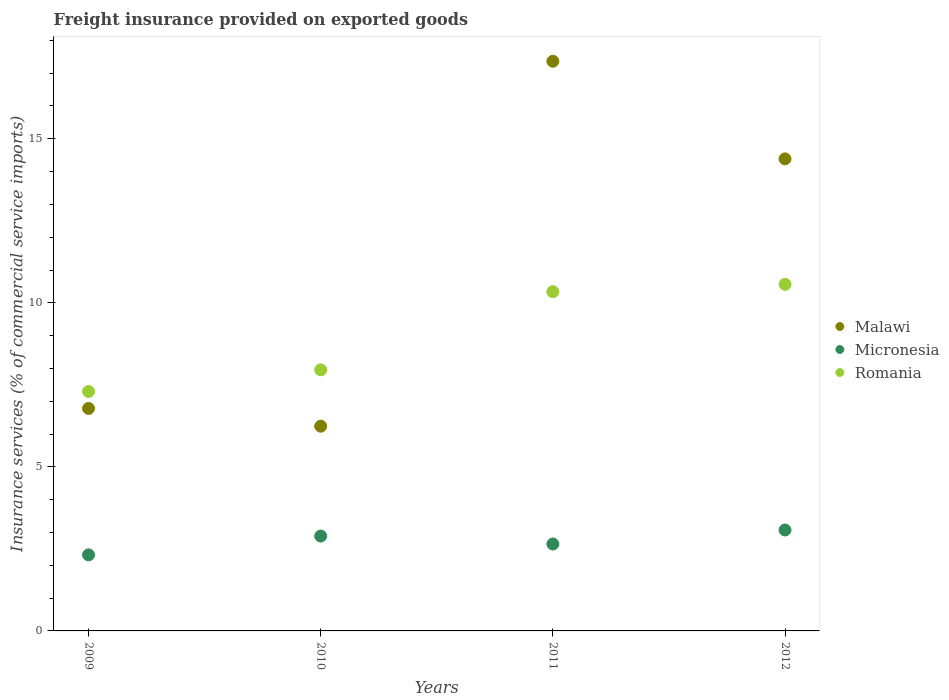Is the number of dotlines equal to the number of legend labels?
Provide a succinct answer. Yes. What is the freight insurance provided on exported goods in Romania in 2011?
Provide a short and direct response. 10.34. Across all years, what is the maximum freight insurance provided on exported goods in Micronesia?
Your answer should be very brief. 3.08. Across all years, what is the minimum freight insurance provided on exported goods in Malawi?
Your answer should be compact. 6.24. In which year was the freight insurance provided on exported goods in Malawi maximum?
Provide a short and direct response. 2011. In which year was the freight insurance provided on exported goods in Malawi minimum?
Provide a succinct answer. 2010. What is the total freight insurance provided on exported goods in Micronesia in the graph?
Make the answer very short. 10.94. What is the difference between the freight insurance provided on exported goods in Romania in 2009 and that in 2011?
Offer a very short reply. -3.04. What is the difference between the freight insurance provided on exported goods in Malawi in 2011 and the freight insurance provided on exported goods in Romania in 2012?
Offer a terse response. 6.8. What is the average freight insurance provided on exported goods in Romania per year?
Provide a succinct answer. 9.04. In the year 2011, what is the difference between the freight insurance provided on exported goods in Romania and freight insurance provided on exported goods in Micronesia?
Ensure brevity in your answer.  7.69. What is the ratio of the freight insurance provided on exported goods in Micronesia in 2010 to that in 2011?
Ensure brevity in your answer.  1.09. What is the difference between the highest and the second highest freight insurance provided on exported goods in Malawi?
Keep it short and to the point. 2.98. What is the difference between the highest and the lowest freight insurance provided on exported goods in Romania?
Your answer should be very brief. 3.27. Does the freight insurance provided on exported goods in Malawi monotonically increase over the years?
Make the answer very short. No. Is the freight insurance provided on exported goods in Micronesia strictly greater than the freight insurance provided on exported goods in Romania over the years?
Offer a very short reply. No. Is the freight insurance provided on exported goods in Malawi strictly less than the freight insurance provided on exported goods in Micronesia over the years?
Ensure brevity in your answer.  No. Are the values on the major ticks of Y-axis written in scientific E-notation?
Your response must be concise. No. Does the graph contain any zero values?
Provide a short and direct response. No. How many legend labels are there?
Offer a very short reply. 3. What is the title of the graph?
Your answer should be compact. Freight insurance provided on exported goods. Does "Saudi Arabia" appear as one of the legend labels in the graph?
Give a very brief answer. No. What is the label or title of the X-axis?
Ensure brevity in your answer.  Years. What is the label or title of the Y-axis?
Offer a very short reply. Insurance services (% of commercial service imports). What is the Insurance services (% of commercial service imports) of Malawi in 2009?
Provide a short and direct response. 6.78. What is the Insurance services (% of commercial service imports) in Micronesia in 2009?
Provide a short and direct response. 2.32. What is the Insurance services (% of commercial service imports) of Romania in 2009?
Offer a terse response. 7.3. What is the Insurance services (% of commercial service imports) of Malawi in 2010?
Make the answer very short. 6.24. What is the Insurance services (% of commercial service imports) of Micronesia in 2010?
Provide a short and direct response. 2.89. What is the Insurance services (% of commercial service imports) of Romania in 2010?
Provide a succinct answer. 7.96. What is the Insurance services (% of commercial service imports) of Malawi in 2011?
Keep it short and to the point. 17.36. What is the Insurance services (% of commercial service imports) of Micronesia in 2011?
Your answer should be very brief. 2.65. What is the Insurance services (% of commercial service imports) of Romania in 2011?
Provide a short and direct response. 10.34. What is the Insurance services (% of commercial service imports) in Malawi in 2012?
Make the answer very short. 14.39. What is the Insurance services (% of commercial service imports) in Micronesia in 2012?
Your response must be concise. 3.08. What is the Insurance services (% of commercial service imports) of Romania in 2012?
Offer a terse response. 10.56. Across all years, what is the maximum Insurance services (% of commercial service imports) of Malawi?
Your response must be concise. 17.36. Across all years, what is the maximum Insurance services (% of commercial service imports) in Micronesia?
Offer a terse response. 3.08. Across all years, what is the maximum Insurance services (% of commercial service imports) of Romania?
Your response must be concise. 10.56. Across all years, what is the minimum Insurance services (% of commercial service imports) in Malawi?
Offer a very short reply. 6.24. Across all years, what is the minimum Insurance services (% of commercial service imports) in Micronesia?
Make the answer very short. 2.32. Across all years, what is the minimum Insurance services (% of commercial service imports) of Romania?
Your answer should be compact. 7.3. What is the total Insurance services (% of commercial service imports) of Malawi in the graph?
Keep it short and to the point. 44.77. What is the total Insurance services (% of commercial service imports) in Micronesia in the graph?
Offer a very short reply. 10.94. What is the total Insurance services (% of commercial service imports) of Romania in the graph?
Make the answer very short. 36.16. What is the difference between the Insurance services (% of commercial service imports) of Malawi in 2009 and that in 2010?
Make the answer very short. 0.54. What is the difference between the Insurance services (% of commercial service imports) of Micronesia in 2009 and that in 2010?
Your answer should be compact. -0.57. What is the difference between the Insurance services (% of commercial service imports) of Romania in 2009 and that in 2010?
Provide a succinct answer. -0.66. What is the difference between the Insurance services (% of commercial service imports) of Malawi in 2009 and that in 2011?
Make the answer very short. -10.58. What is the difference between the Insurance services (% of commercial service imports) in Micronesia in 2009 and that in 2011?
Provide a succinct answer. -0.33. What is the difference between the Insurance services (% of commercial service imports) of Romania in 2009 and that in 2011?
Offer a very short reply. -3.04. What is the difference between the Insurance services (% of commercial service imports) in Malawi in 2009 and that in 2012?
Offer a very short reply. -7.61. What is the difference between the Insurance services (% of commercial service imports) in Micronesia in 2009 and that in 2012?
Offer a terse response. -0.76. What is the difference between the Insurance services (% of commercial service imports) of Romania in 2009 and that in 2012?
Keep it short and to the point. -3.27. What is the difference between the Insurance services (% of commercial service imports) in Malawi in 2010 and that in 2011?
Your answer should be very brief. -11.12. What is the difference between the Insurance services (% of commercial service imports) in Micronesia in 2010 and that in 2011?
Your answer should be compact. 0.24. What is the difference between the Insurance services (% of commercial service imports) in Romania in 2010 and that in 2011?
Your answer should be very brief. -2.38. What is the difference between the Insurance services (% of commercial service imports) in Malawi in 2010 and that in 2012?
Make the answer very short. -8.15. What is the difference between the Insurance services (% of commercial service imports) in Micronesia in 2010 and that in 2012?
Offer a very short reply. -0.18. What is the difference between the Insurance services (% of commercial service imports) in Romania in 2010 and that in 2012?
Ensure brevity in your answer.  -2.61. What is the difference between the Insurance services (% of commercial service imports) in Malawi in 2011 and that in 2012?
Ensure brevity in your answer.  2.98. What is the difference between the Insurance services (% of commercial service imports) in Micronesia in 2011 and that in 2012?
Your answer should be very brief. -0.43. What is the difference between the Insurance services (% of commercial service imports) in Romania in 2011 and that in 2012?
Provide a short and direct response. -0.23. What is the difference between the Insurance services (% of commercial service imports) in Malawi in 2009 and the Insurance services (% of commercial service imports) in Micronesia in 2010?
Give a very brief answer. 3.89. What is the difference between the Insurance services (% of commercial service imports) in Malawi in 2009 and the Insurance services (% of commercial service imports) in Romania in 2010?
Provide a succinct answer. -1.18. What is the difference between the Insurance services (% of commercial service imports) in Micronesia in 2009 and the Insurance services (% of commercial service imports) in Romania in 2010?
Keep it short and to the point. -5.64. What is the difference between the Insurance services (% of commercial service imports) in Malawi in 2009 and the Insurance services (% of commercial service imports) in Micronesia in 2011?
Provide a succinct answer. 4.13. What is the difference between the Insurance services (% of commercial service imports) in Malawi in 2009 and the Insurance services (% of commercial service imports) in Romania in 2011?
Make the answer very short. -3.56. What is the difference between the Insurance services (% of commercial service imports) of Micronesia in 2009 and the Insurance services (% of commercial service imports) of Romania in 2011?
Provide a succinct answer. -8.02. What is the difference between the Insurance services (% of commercial service imports) in Malawi in 2009 and the Insurance services (% of commercial service imports) in Micronesia in 2012?
Provide a succinct answer. 3.71. What is the difference between the Insurance services (% of commercial service imports) of Malawi in 2009 and the Insurance services (% of commercial service imports) of Romania in 2012?
Keep it short and to the point. -3.78. What is the difference between the Insurance services (% of commercial service imports) in Micronesia in 2009 and the Insurance services (% of commercial service imports) in Romania in 2012?
Give a very brief answer. -8.25. What is the difference between the Insurance services (% of commercial service imports) of Malawi in 2010 and the Insurance services (% of commercial service imports) of Micronesia in 2011?
Your answer should be compact. 3.59. What is the difference between the Insurance services (% of commercial service imports) in Malawi in 2010 and the Insurance services (% of commercial service imports) in Romania in 2011?
Your answer should be compact. -4.1. What is the difference between the Insurance services (% of commercial service imports) in Micronesia in 2010 and the Insurance services (% of commercial service imports) in Romania in 2011?
Offer a terse response. -7.45. What is the difference between the Insurance services (% of commercial service imports) in Malawi in 2010 and the Insurance services (% of commercial service imports) in Micronesia in 2012?
Offer a very short reply. 3.16. What is the difference between the Insurance services (% of commercial service imports) in Malawi in 2010 and the Insurance services (% of commercial service imports) in Romania in 2012?
Offer a terse response. -4.32. What is the difference between the Insurance services (% of commercial service imports) of Micronesia in 2010 and the Insurance services (% of commercial service imports) of Romania in 2012?
Offer a terse response. -7.67. What is the difference between the Insurance services (% of commercial service imports) in Malawi in 2011 and the Insurance services (% of commercial service imports) in Micronesia in 2012?
Your response must be concise. 14.29. What is the difference between the Insurance services (% of commercial service imports) in Malawi in 2011 and the Insurance services (% of commercial service imports) in Romania in 2012?
Ensure brevity in your answer.  6.8. What is the difference between the Insurance services (% of commercial service imports) in Micronesia in 2011 and the Insurance services (% of commercial service imports) in Romania in 2012?
Offer a very short reply. -7.91. What is the average Insurance services (% of commercial service imports) in Malawi per year?
Your response must be concise. 11.19. What is the average Insurance services (% of commercial service imports) of Micronesia per year?
Your answer should be compact. 2.73. What is the average Insurance services (% of commercial service imports) in Romania per year?
Ensure brevity in your answer.  9.04. In the year 2009, what is the difference between the Insurance services (% of commercial service imports) of Malawi and Insurance services (% of commercial service imports) of Micronesia?
Provide a succinct answer. 4.46. In the year 2009, what is the difference between the Insurance services (% of commercial service imports) in Malawi and Insurance services (% of commercial service imports) in Romania?
Provide a succinct answer. -0.52. In the year 2009, what is the difference between the Insurance services (% of commercial service imports) of Micronesia and Insurance services (% of commercial service imports) of Romania?
Your answer should be compact. -4.98. In the year 2010, what is the difference between the Insurance services (% of commercial service imports) in Malawi and Insurance services (% of commercial service imports) in Micronesia?
Provide a succinct answer. 3.35. In the year 2010, what is the difference between the Insurance services (% of commercial service imports) in Malawi and Insurance services (% of commercial service imports) in Romania?
Provide a short and direct response. -1.72. In the year 2010, what is the difference between the Insurance services (% of commercial service imports) in Micronesia and Insurance services (% of commercial service imports) in Romania?
Offer a terse response. -5.07. In the year 2011, what is the difference between the Insurance services (% of commercial service imports) of Malawi and Insurance services (% of commercial service imports) of Micronesia?
Your response must be concise. 14.71. In the year 2011, what is the difference between the Insurance services (% of commercial service imports) in Malawi and Insurance services (% of commercial service imports) in Romania?
Provide a succinct answer. 7.02. In the year 2011, what is the difference between the Insurance services (% of commercial service imports) of Micronesia and Insurance services (% of commercial service imports) of Romania?
Provide a short and direct response. -7.69. In the year 2012, what is the difference between the Insurance services (% of commercial service imports) in Malawi and Insurance services (% of commercial service imports) in Micronesia?
Offer a terse response. 11.31. In the year 2012, what is the difference between the Insurance services (% of commercial service imports) of Malawi and Insurance services (% of commercial service imports) of Romania?
Your response must be concise. 3.82. In the year 2012, what is the difference between the Insurance services (% of commercial service imports) in Micronesia and Insurance services (% of commercial service imports) in Romania?
Provide a short and direct response. -7.49. What is the ratio of the Insurance services (% of commercial service imports) of Malawi in 2009 to that in 2010?
Ensure brevity in your answer.  1.09. What is the ratio of the Insurance services (% of commercial service imports) in Micronesia in 2009 to that in 2010?
Ensure brevity in your answer.  0.8. What is the ratio of the Insurance services (% of commercial service imports) of Romania in 2009 to that in 2010?
Offer a terse response. 0.92. What is the ratio of the Insurance services (% of commercial service imports) in Malawi in 2009 to that in 2011?
Offer a very short reply. 0.39. What is the ratio of the Insurance services (% of commercial service imports) in Micronesia in 2009 to that in 2011?
Your answer should be compact. 0.87. What is the ratio of the Insurance services (% of commercial service imports) in Romania in 2009 to that in 2011?
Your response must be concise. 0.71. What is the ratio of the Insurance services (% of commercial service imports) of Malawi in 2009 to that in 2012?
Offer a very short reply. 0.47. What is the ratio of the Insurance services (% of commercial service imports) of Micronesia in 2009 to that in 2012?
Offer a very short reply. 0.75. What is the ratio of the Insurance services (% of commercial service imports) in Romania in 2009 to that in 2012?
Offer a terse response. 0.69. What is the ratio of the Insurance services (% of commercial service imports) of Malawi in 2010 to that in 2011?
Offer a very short reply. 0.36. What is the ratio of the Insurance services (% of commercial service imports) of Micronesia in 2010 to that in 2011?
Provide a succinct answer. 1.09. What is the ratio of the Insurance services (% of commercial service imports) of Romania in 2010 to that in 2011?
Keep it short and to the point. 0.77. What is the ratio of the Insurance services (% of commercial service imports) of Malawi in 2010 to that in 2012?
Keep it short and to the point. 0.43. What is the ratio of the Insurance services (% of commercial service imports) of Micronesia in 2010 to that in 2012?
Provide a succinct answer. 0.94. What is the ratio of the Insurance services (% of commercial service imports) of Romania in 2010 to that in 2012?
Your answer should be very brief. 0.75. What is the ratio of the Insurance services (% of commercial service imports) in Malawi in 2011 to that in 2012?
Make the answer very short. 1.21. What is the ratio of the Insurance services (% of commercial service imports) of Micronesia in 2011 to that in 2012?
Provide a succinct answer. 0.86. What is the ratio of the Insurance services (% of commercial service imports) in Romania in 2011 to that in 2012?
Your answer should be compact. 0.98. What is the difference between the highest and the second highest Insurance services (% of commercial service imports) of Malawi?
Offer a terse response. 2.98. What is the difference between the highest and the second highest Insurance services (% of commercial service imports) in Micronesia?
Your answer should be compact. 0.18. What is the difference between the highest and the second highest Insurance services (% of commercial service imports) in Romania?
Ensure brevity in your answer.  0.23. What is the difference between the highest and the lowest Insurance services (% of commercial service imports) of Malawi?
Your answer should be compact. 11.12. What is the difference between the highest and the lowest Insurance services (% of commercial service imports) of Micronesia?
Give a very brief answer. 0.76. What is the difference between the highest and the lowest Insurance services (% of commercial service imports) in Romania?
Ensure brevity in your answer.  3.27. 